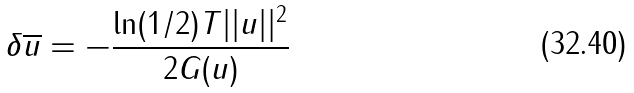<formula> <loc_0><loc_0><loc_500><loc_500>\delta \overline { u } = - \frac { \ln ( 1 / 2 ) T | | u | | ^ { 2 } } { 2 G ( u ) }</formula> 